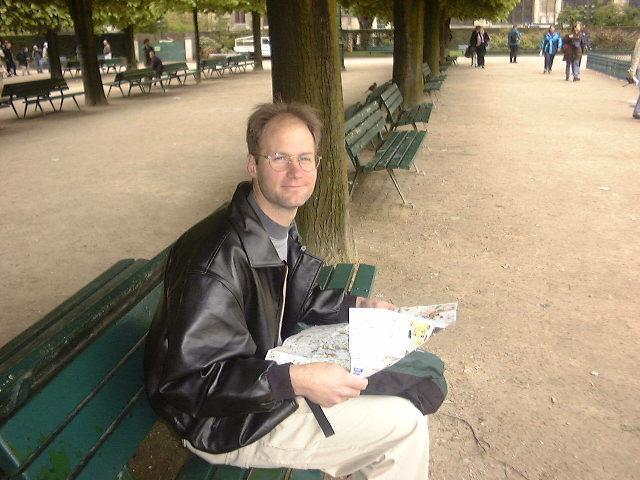How many benches are there?
Give a very brief answer. 2. 